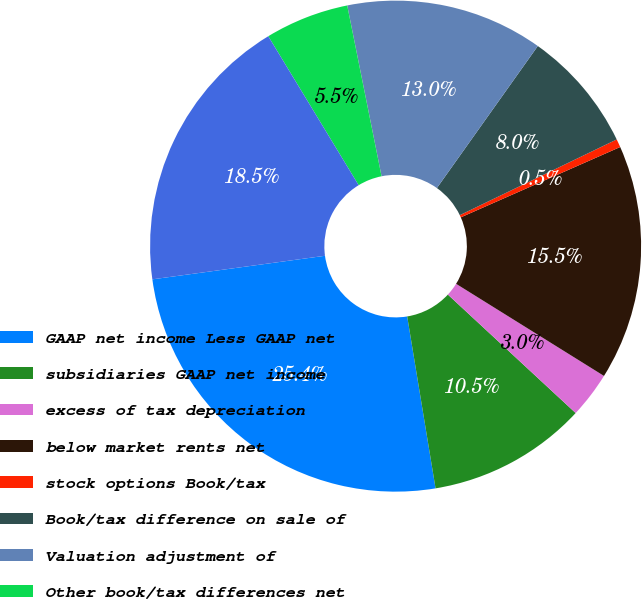<chart> <loc_0><loc_0><loc_500><loc_500><pie_chart><fcel>GAAP net income Less GAAP net<fcel>subsidiaries GAAP net income<fcel>excess of tax depreciation<fcel>below market rents net<fcel>stock options Book/tax<fcel>Book/tax difference on sale of<fcel>Valuation adjustment of<fcel>Other book/tax differences net<fcel>Adjusted taxable income<nl><fcel>25.44%<fcel>10.5%<fcel>3.03%<fcel>15.48%<fcel>0.54%<fcel>8.01%<fcel>12.99%<fcel>5.52%<fcel>18.48%<nl></chart> 